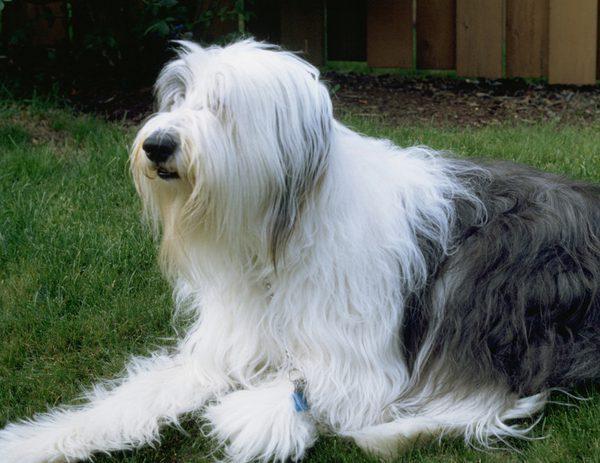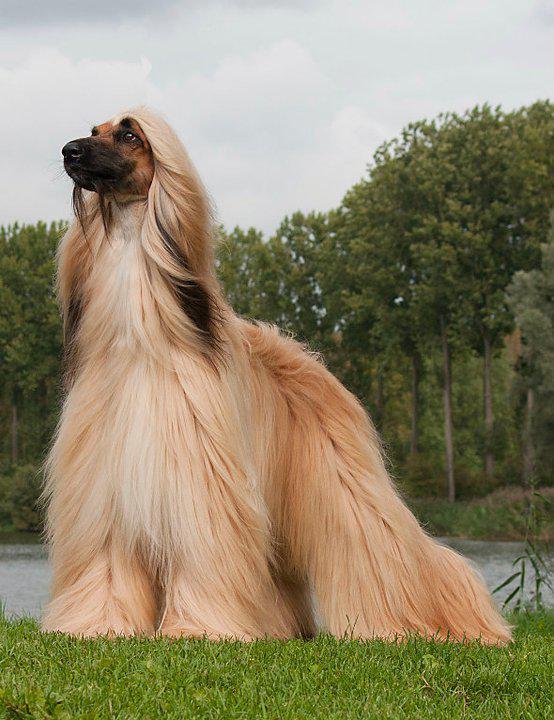The first image is the image on the left, the second image is the image on the right. Examine the images to the left and right. Is the description "One dog is standing on all fours, and the other dog is reclining with raised head and outstretched front paws on the grass." accurate? Answer yes or no. Yes. 